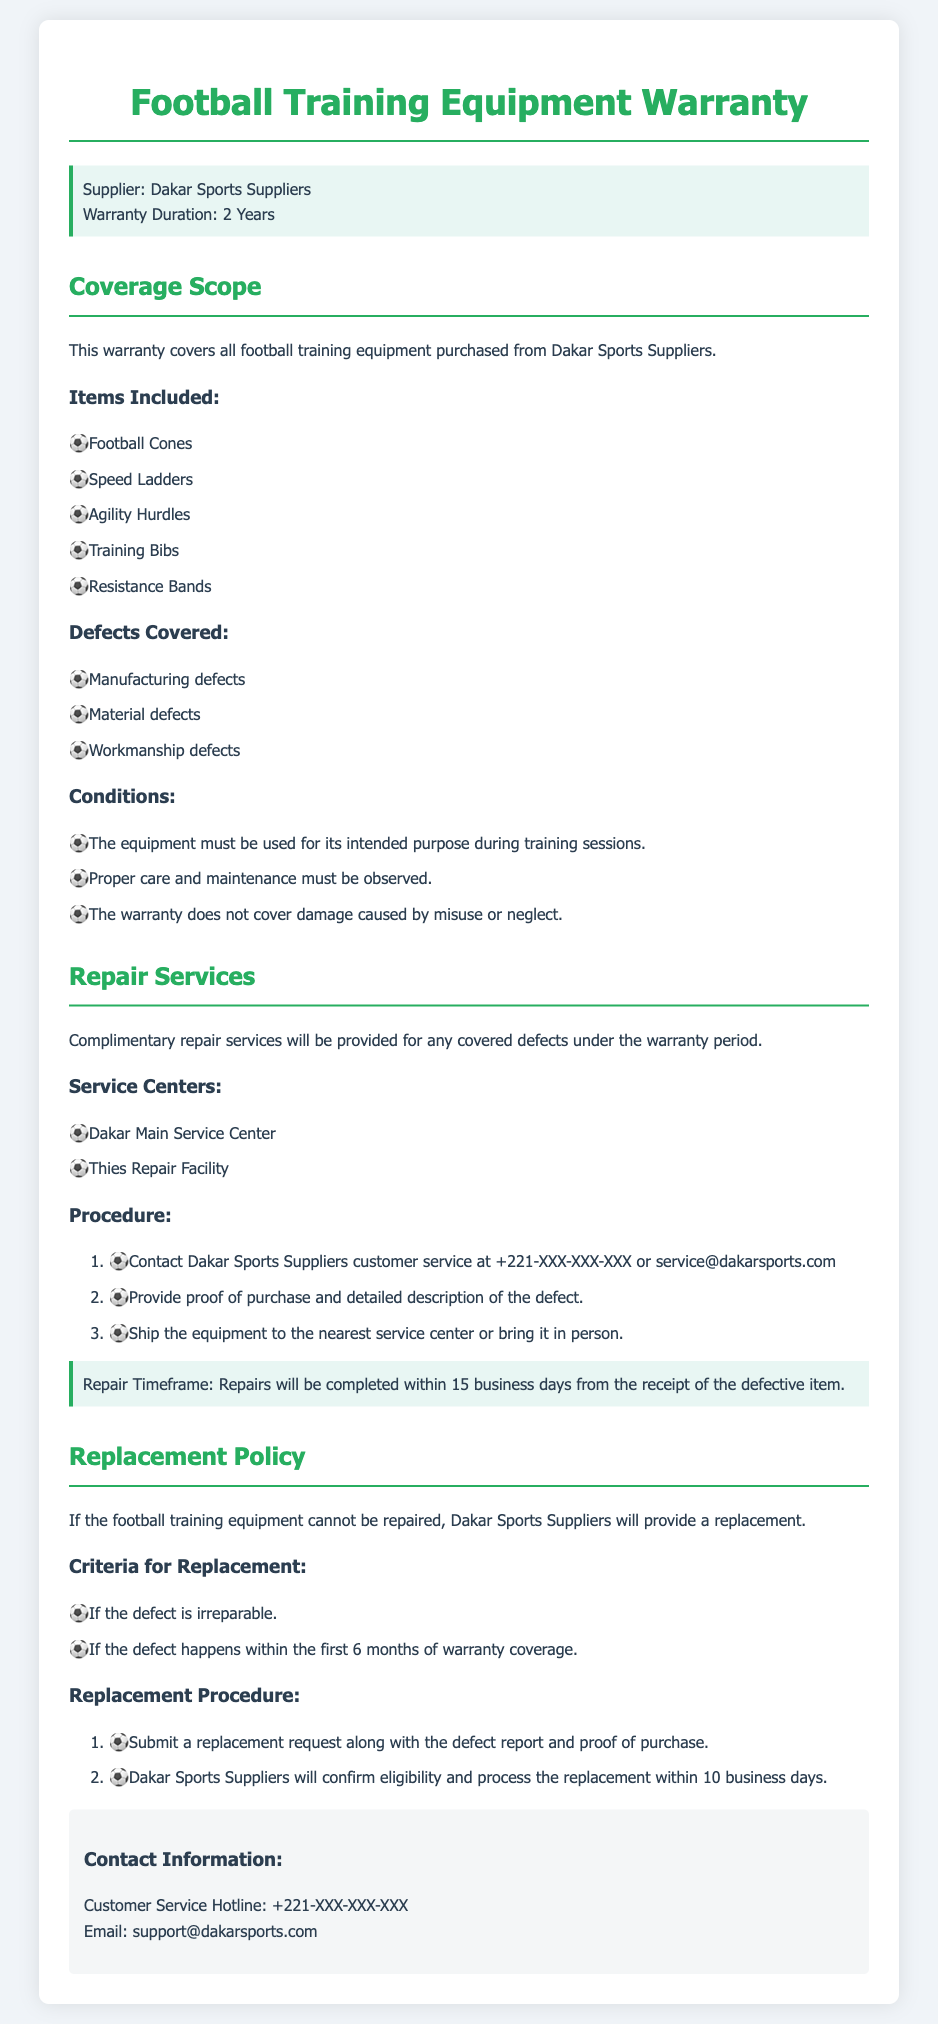What is the warranty duration? The warranty duration is stated directly in the document, which is 2 Years.
Answer: 2 Years Which items are included under the warranty? The document lists the specific items covered under the warranty, including Football Cones, Speed Ladders, Agility Hurdles, Training Bibs, and Resistance Bands.
Answer: Football Cones, Speed Ladders, Agility Hurdles, Training Bibs, Resistance Bands What defects are covered? The document outlines the types of defects that are covered, including Manufacturing defects, Material defects, and Workmanship defects.
Answer: Manufacturing defects, Material defects, Workmanship defects What is the repair timeframe? The repair timeframe is indicated in the warranty document, stating repairs will be completed within 15 business days from receipt of the defective item.
Answer: 15 business days What must be submitted for a replacement request? The document specifies that a replacement request must include a defect report and proof of purchase.
Answer: Defect report and proof of purchase Where can repairs be serviced? The document lists the locations where repairs can be serviced, specifically at Dakar Main Service Center and Thies Repair Facility.
Answer: Dakar Main Service Center, Thies Repair Facility Under what condition will a replacement be provided? The document outlines that a replacement will be provided if the defect is irreparable or occurs within the first 6 months of warranty coverage.
Answer: Irreparable defect or within the first 6 months Who to contact for customer service? The document provides customer service contact information, including a hotline and an email address for support.
Answer: +221-XXX-XXX-XXX; support@dakarsports.com 